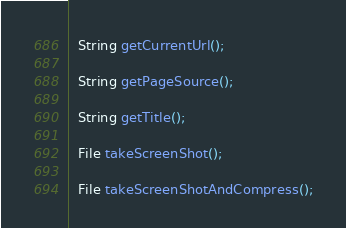Convert code to text. <code><loc_0><loc_0><loc_500><loc_500><_Java_>
  String getCurrentUrl();

  String getPageSource();

  String getTitle();

  File takeScreenShot();

  File takeScreenShotAndCompress();
</code> 